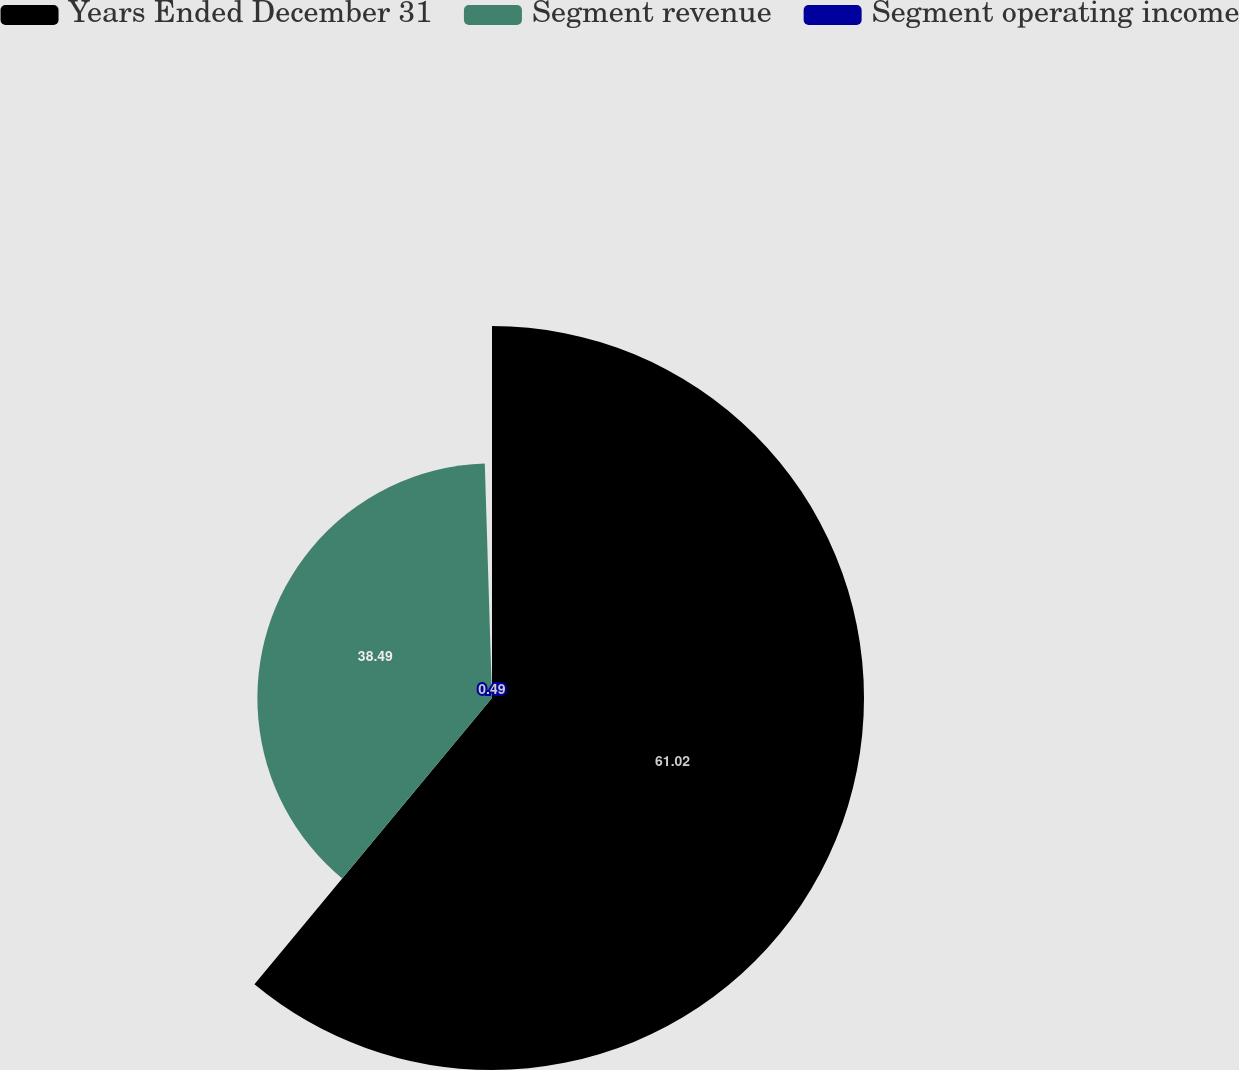Convert chart. <chart><loc_0><loc_0><loc_500><loc_500><pie_chart><fcel>Years Ended December 31<fcel>Segment revenue<fcel>Segment operating income<nl><fcel>61.03%<fcel>38.49%<fcel>0.49%<nl></chart> 